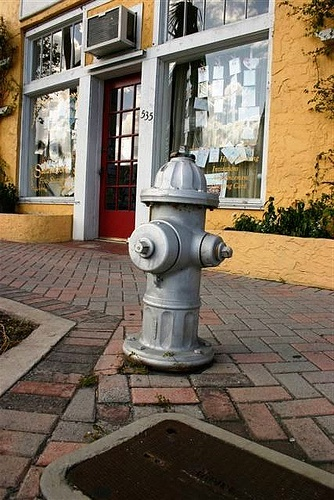Describe the objects in this image and their specific colors. I can see a fire hydrant in tan, gray, darkgray, black, and lightgray tones in this image. 